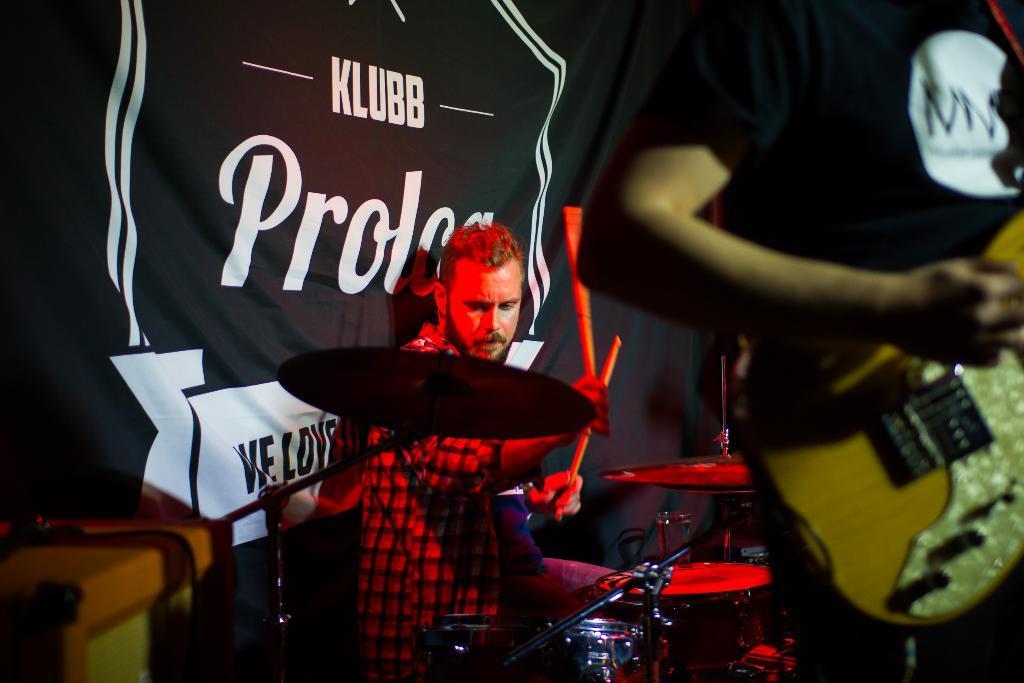In one or two sentences, can you explain what this image depicts? There are two men on the stage, one is holding a guitar in his hand and the other one is playing drums. Behind them, there is a cloth of black color. 